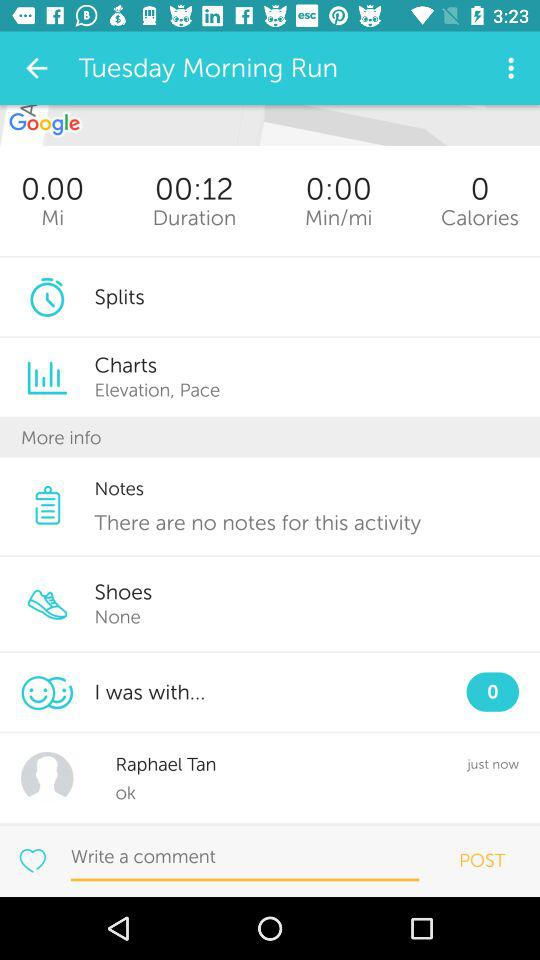How many people was I with? You were with 0 people. 